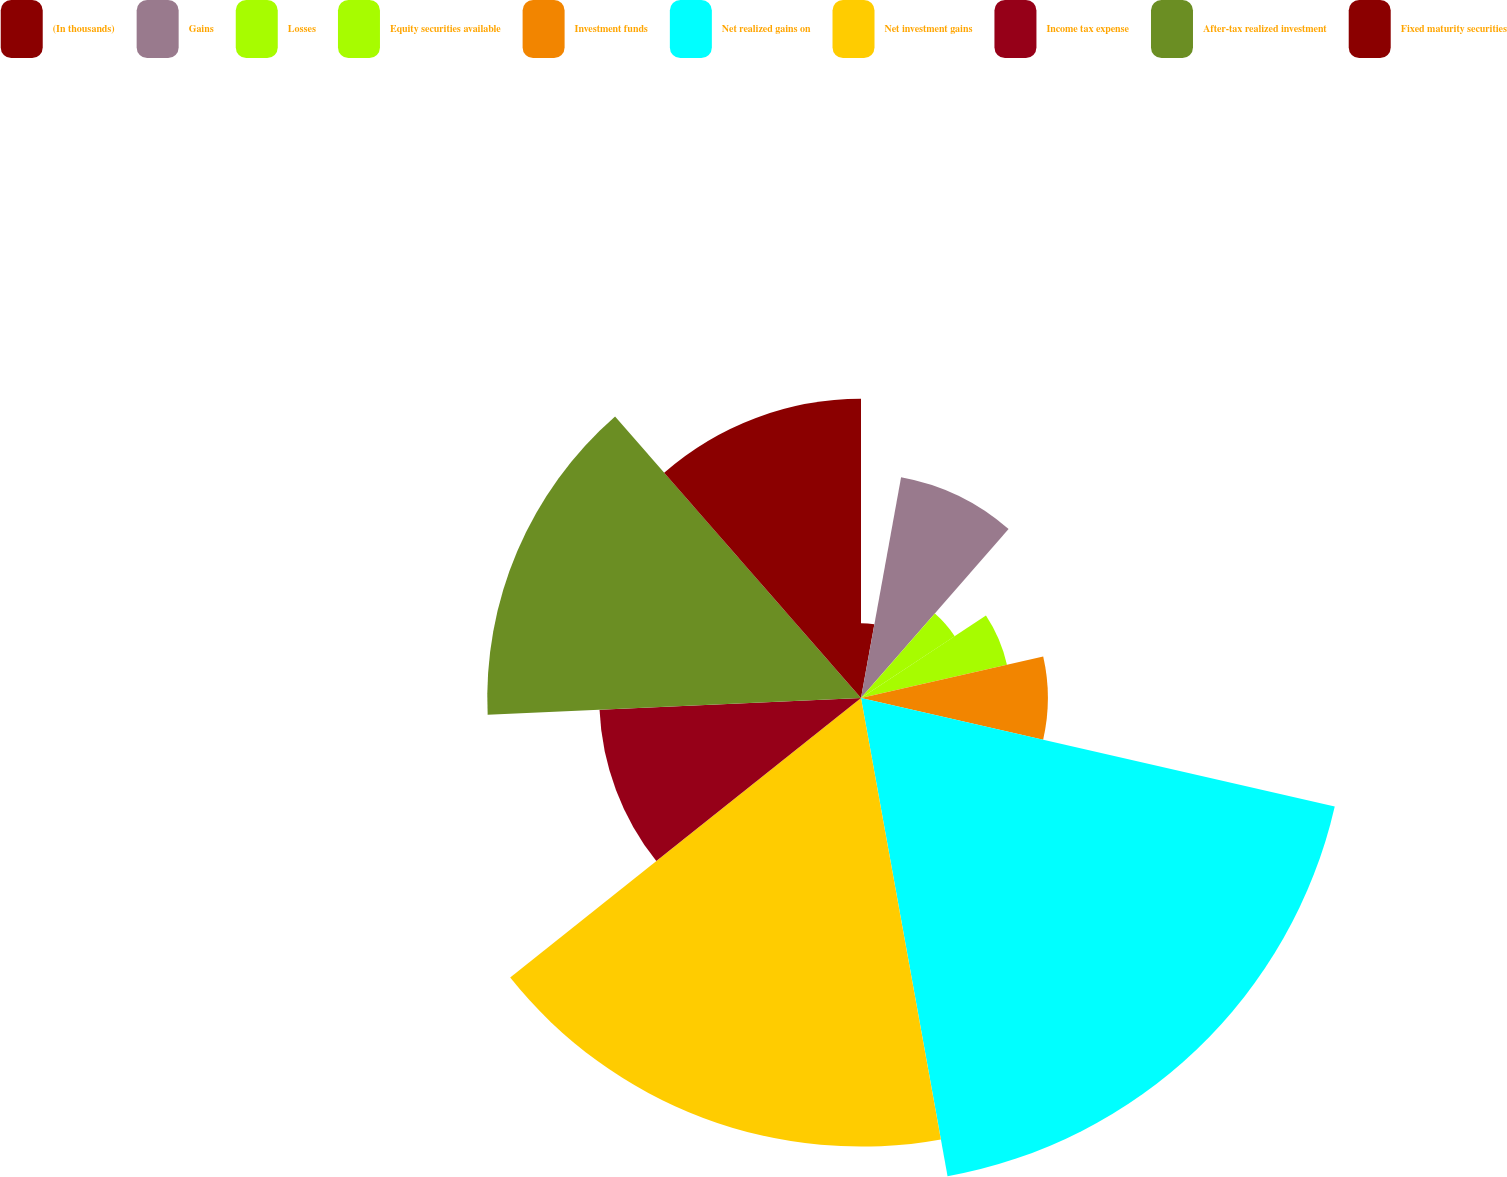<chart> <loc_0><loc_0><loc_500><loc_500><pie_chart><fcel>(In thousands)<fcel>Gains<fcel>Losses<fcel>Equity securities available<fcel>Investment funds<fcel>Net realized gains on<fcel>Net investment gains<fcel>Income tax expense<fcel>After-tax realized investment<fcel>Fixed maturity securities<nl><fcel>2.86%<fcel>8.57%<fcel>4.29%<fcel>5.72%<fcel>7.14%<fcel>18.57%<fcel>17.14%<fcel>10.0%<fcel>14.28%<fcel>11.43%<nl></chart> 